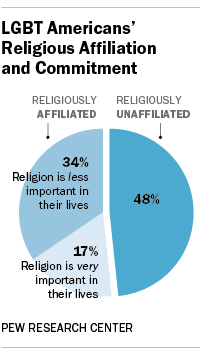Highlight a few significant elements in this photo. How many parts is the graph divided into? It is divided into 3 parts. The average of the graph is 33. 